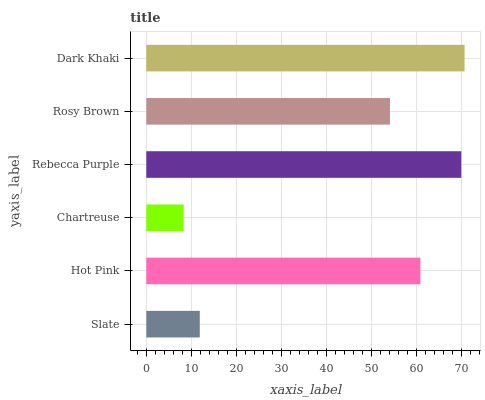Is Chartreuse the minimum?
Answer yes or no. Yes. Is Dark Khaki the maximum?
Answer yes or no. Yes. Is Hot Pink the minimum?
Answer yes or no. No. Is Hot Pink the maximum?
Answer yes or no. No. Is Hot Pink greater than Slate?
Answer yes or no. Yes. Is Slate less than Hot Pink?
Answer yes or no. Yes. Is Slate greater than Hot Pink?
Answer yes or no. No. Is Hot Pink less than Slate?
Answer yes or no. No. Is Hot Pink the high median?
Answer yes or no. Yes. Is Rosy Brown the low median?
Answer yes or no. Yes. Is Chartreuse the high median?
Answer yes or no. No. Is Dark Khaki the low median?
Answer yes or no. No. 